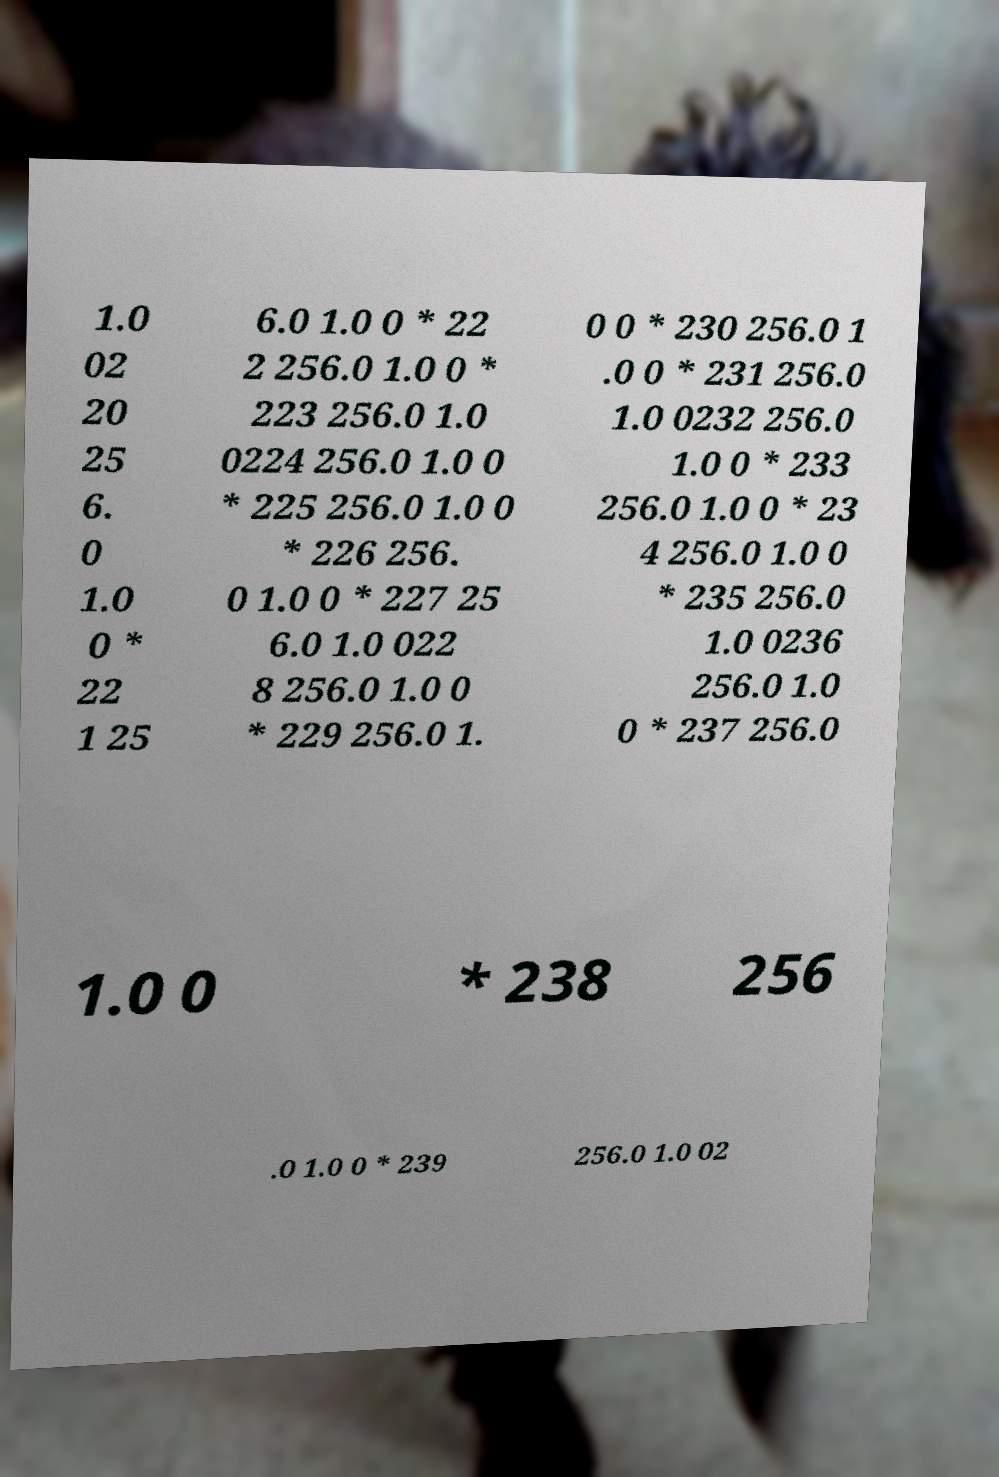For documentation purposes, I need the text within this image transcribed. Could you provide that? 1.0 02 20 25 6. 0 1.0 0 * 22 1 25 6.0 1.0 0 * 22 2 256.0 1.0 0 * 223 256.0 1.0 0224 256.0 1.0 0 * 225 256.0 1.0 0 * 226 256. 0 1.0 0 * 227 25 6.0 1.0 022 8 256.0 1.0 0 * 229 256.0 1. 0 0 * 230 256.0 1 .0 0 * 231 256.0 1.0 0232 256.0 1.0 0 * 233 256.0 1.0 0 * 23 4 256.0 1.0 0 * 235 256.0 1.0 0236 256.0 1.0 0 * 237 256.0 1.0 0 * 238 256 .0 1.0 0 * 239 256.0 1.0 02 